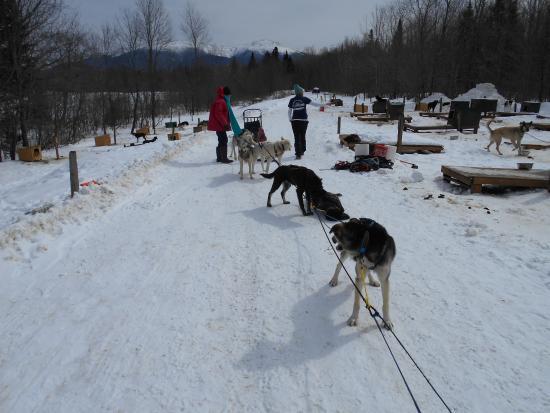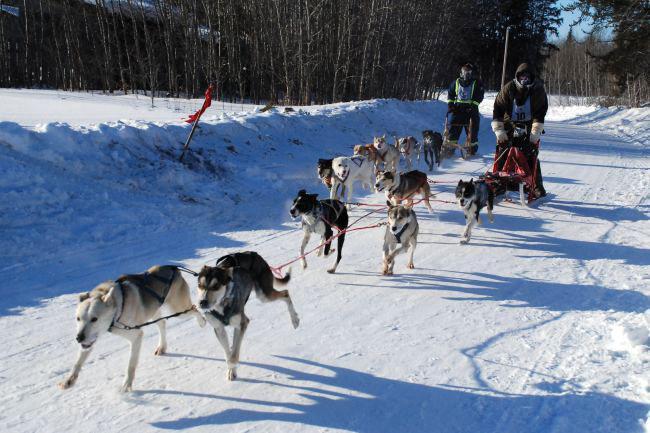The first image is the image on the left, the second image is the image on the right. For the images displayed, is the sentence "There are exactly two people in the image on the left." factually correct? Answer yes or no. Yes. 